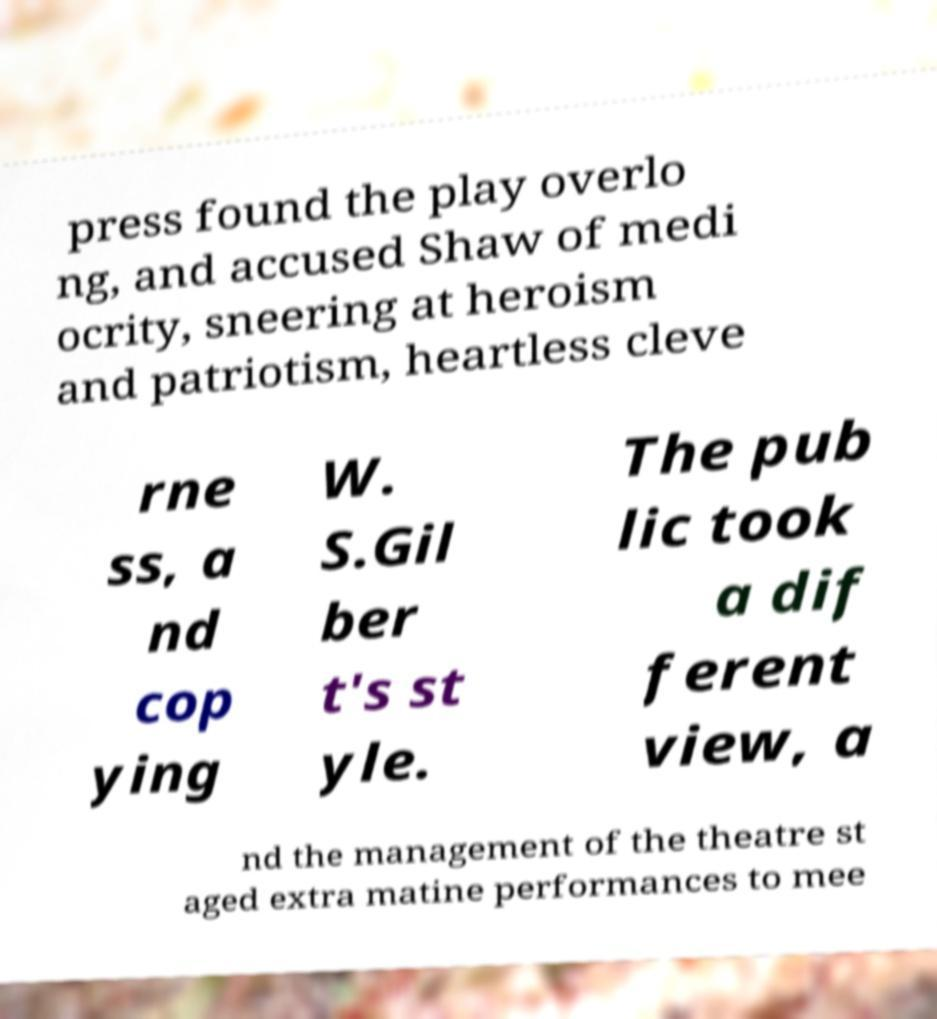Please identify and transcribe the text found in this image. press found the play overlo ng, and accused Shaw of medi ocrity, sneering at heroism and patriotism, heartless cleve rne ss, a nd cop ying W. S.Gil ber t's st yle. The pub lic took a dif ferent view, a nd the management of the theatre st aged extra matine performances to mee 